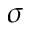<formula> <loc_0><loc_0><loc_500><loc_500>\sigma</formula> 